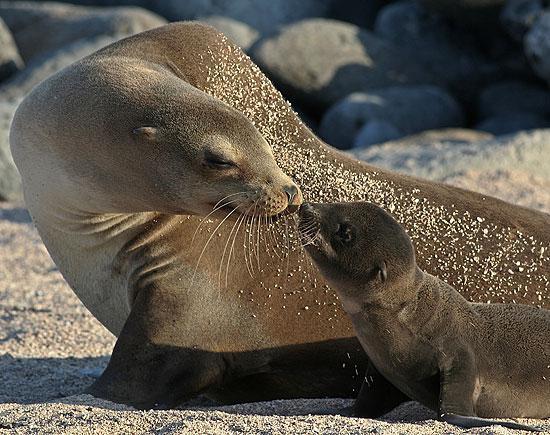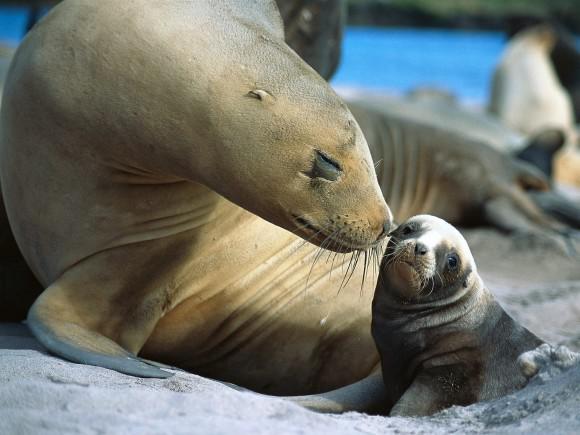The first image is the image on the left, the second image is the image on the right. Examine the images to the left and right. Is the description "Both images show a adult seal with a baby seal." accurate? Answer yes or no. Yes. The first image is the image on the left, the second image is the image on the right. For the images displayed, is the sentence "An adult seal extends its neck to nuzzle a baby seal with its nose in at least one image." factually correct? Answer yes or no. Yes. 